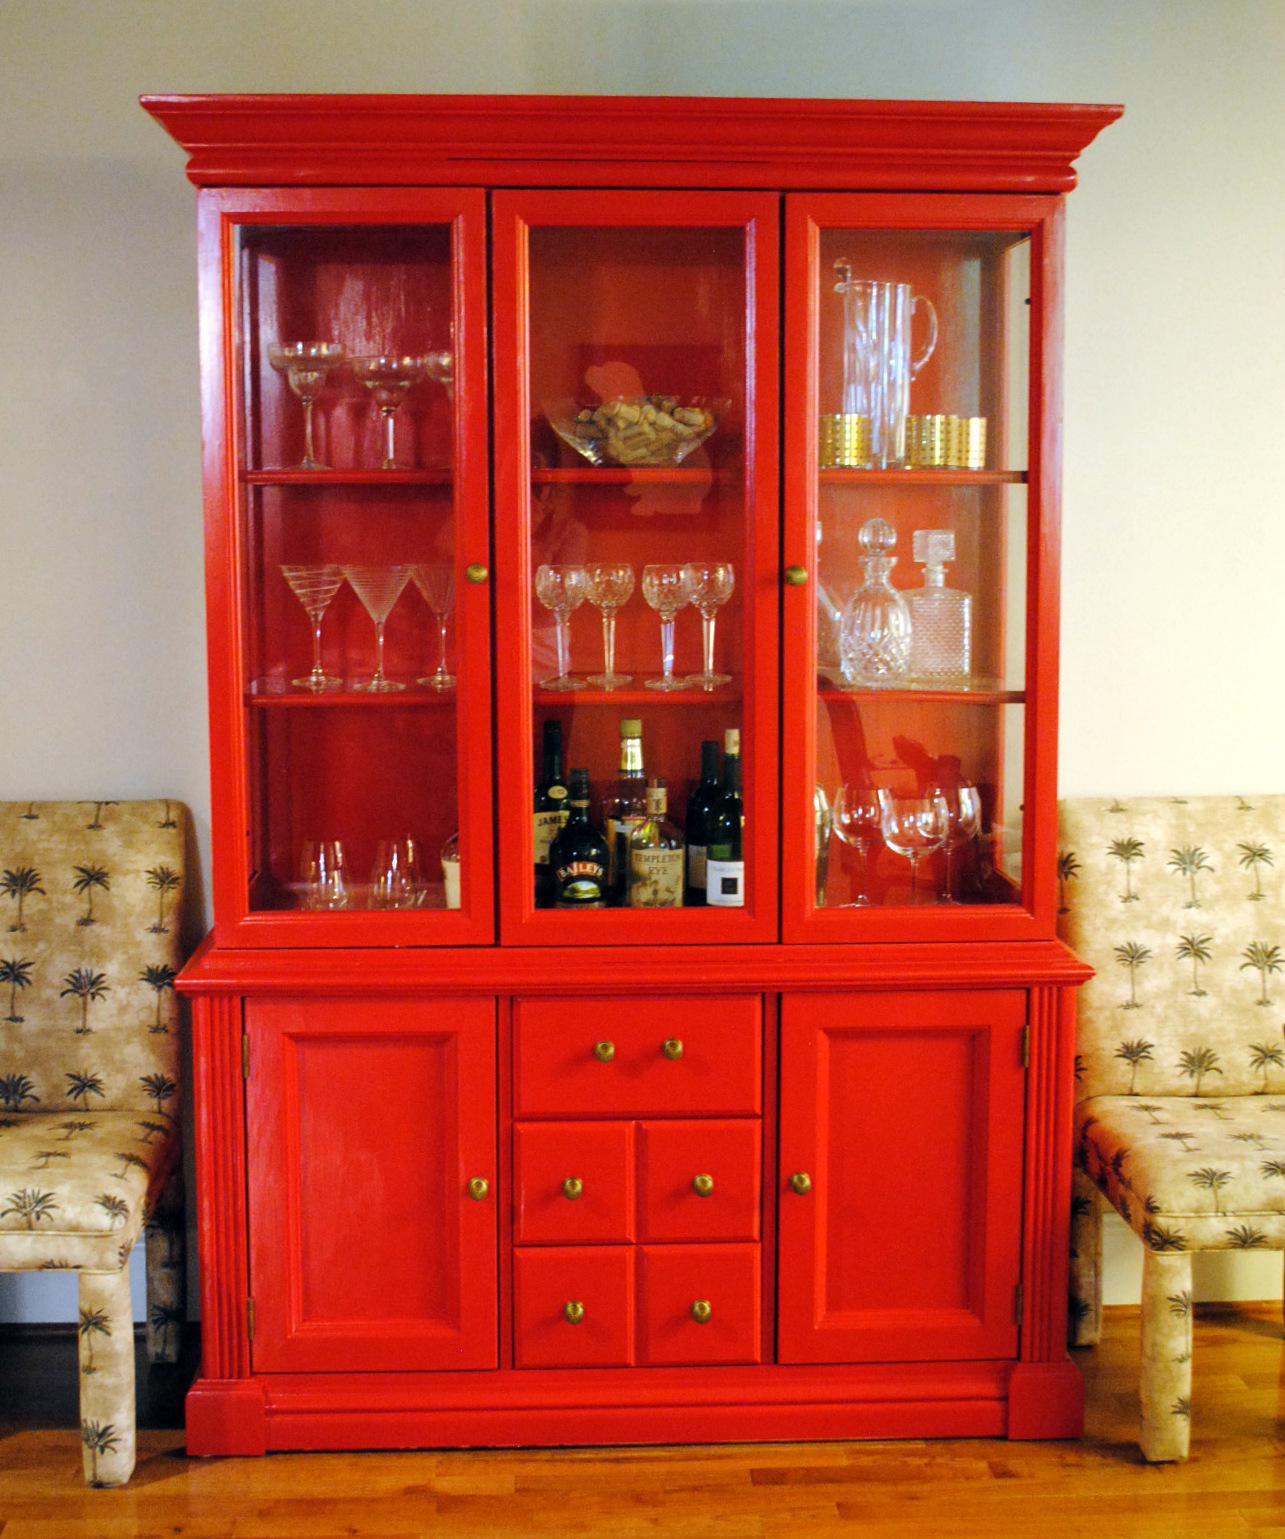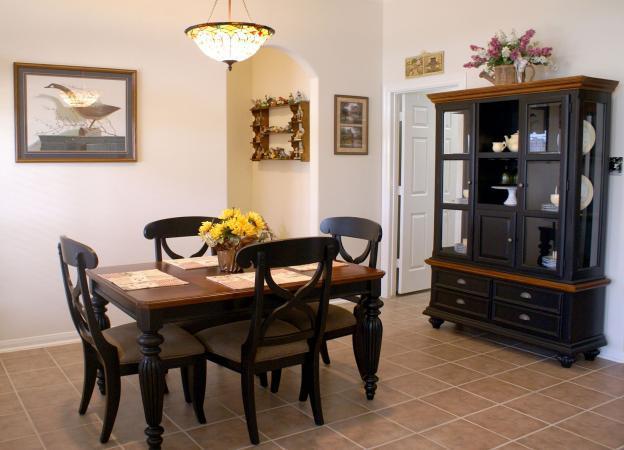The first image is the image on the left, the second image is the image on the right. Examine the images to the left and right. Is the description "None of the cabinets are colored red." accurate? Answer yes or no. No. 